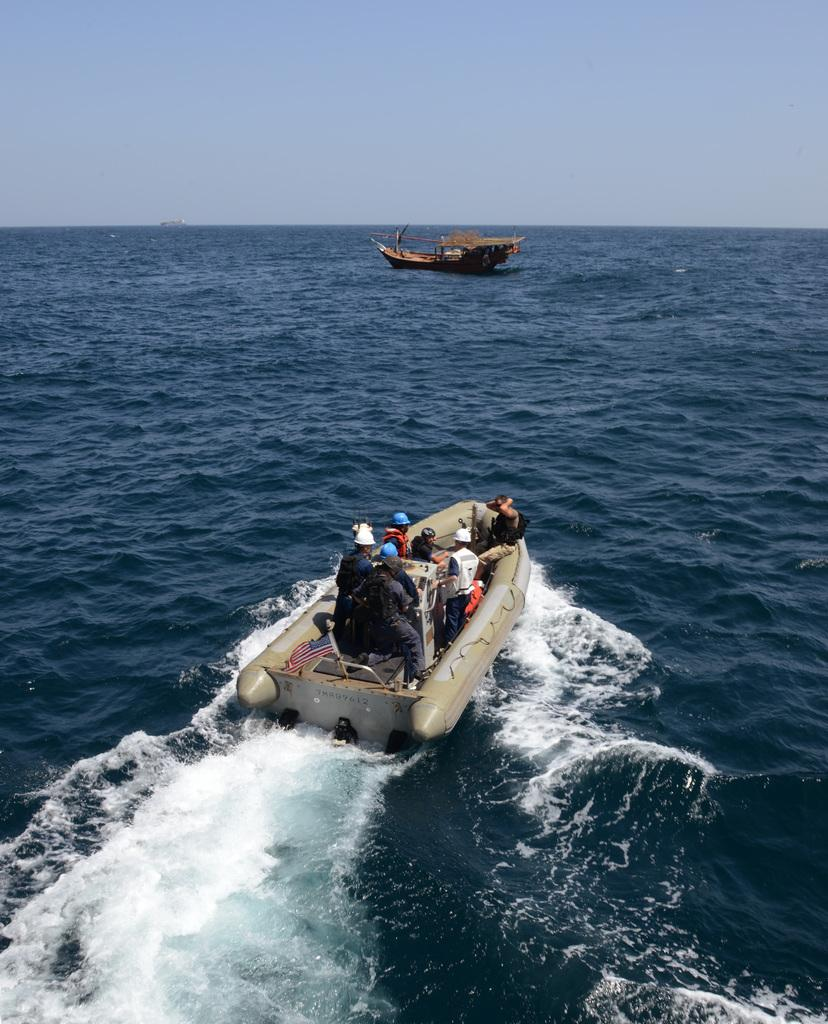What can be seen in the image related to water transportation? There are two boats in the image. Where are the boats located? The boats are on a sea. Are there any people on the boats? Yes, there are people on one of the boats. What is visible in the background of the image? The sky is visible in the background of the image. What type of underwear is the carpenter wearing in the image? There is no carpenter or underwear present in the image. What topic are the people on the boat discussing in the image? The image does not provide information about the conversation or discussion among the people on the boat. 